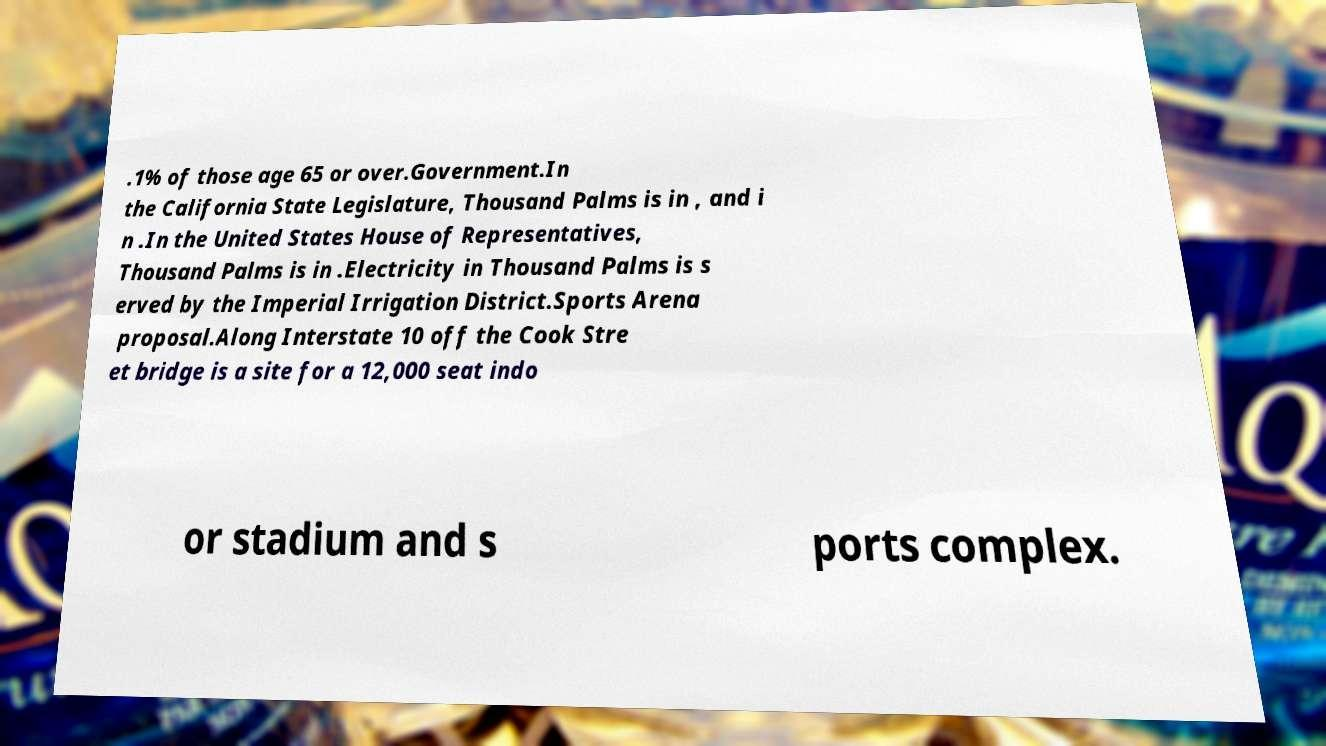Can you accurately transcribe the text from the provided image for me? .1% of those age 65 or over.Government.In the California State Legislature, Thousand Palms is in , and i n .In the United States House of Representatives, Thousand Palms is in .Electricity in Thousand Palms is s erved by the Imperial Irrigation District.Sports Arena proposal.Along Interstate 10 off the Cook Stre et bridge is a site for a 12,000 seat indo or stadium and s ports complex. 